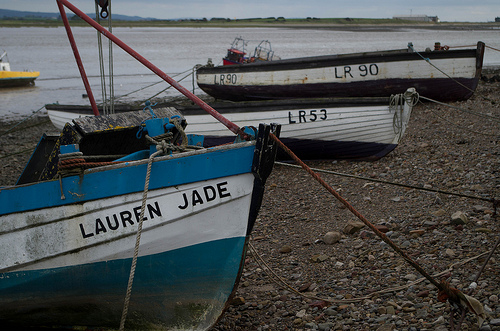What time of day does it appear to be in the image? Given the soft, diffused light and the lack of deep shadows, it seems to be an overcast day, possibly morning or late afternoon. The specific time of day, however, can't be determined precisely without more context. 